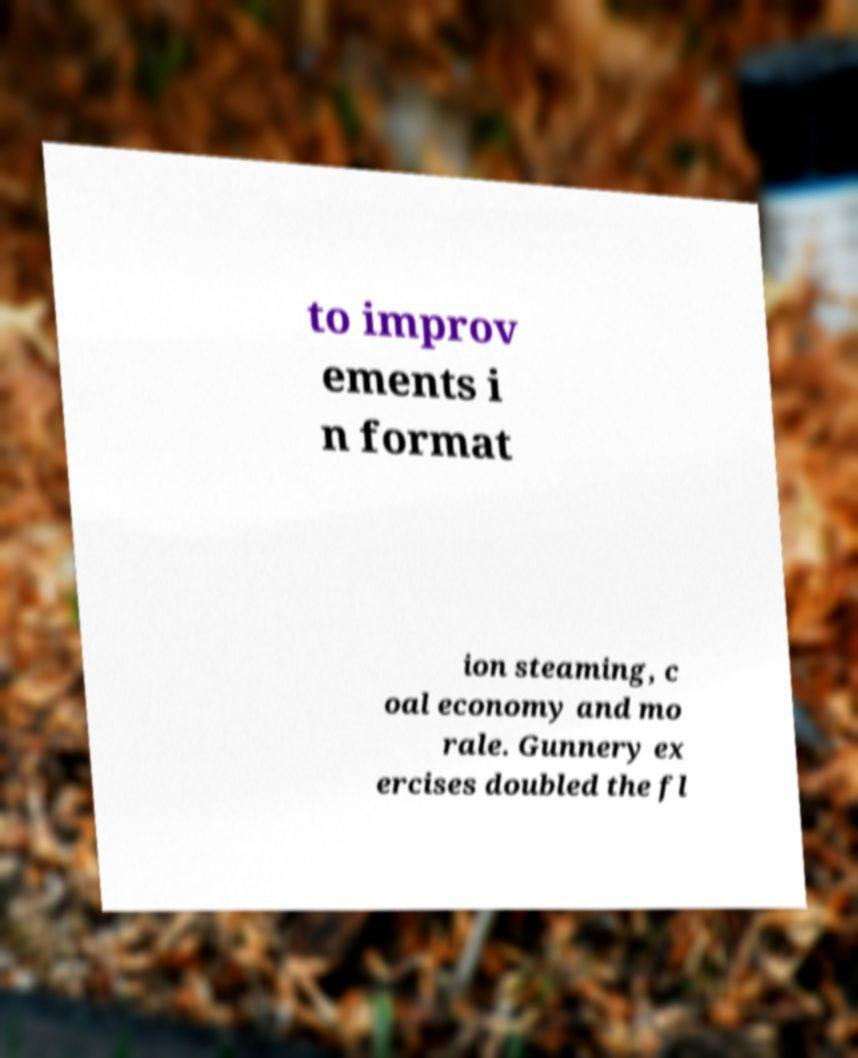Can you accurately transcribe the text from the provided image for me? to improv ements i n format ion steaming, c oal economy and mo rale. Gunnery ex ercises doubled the fl 